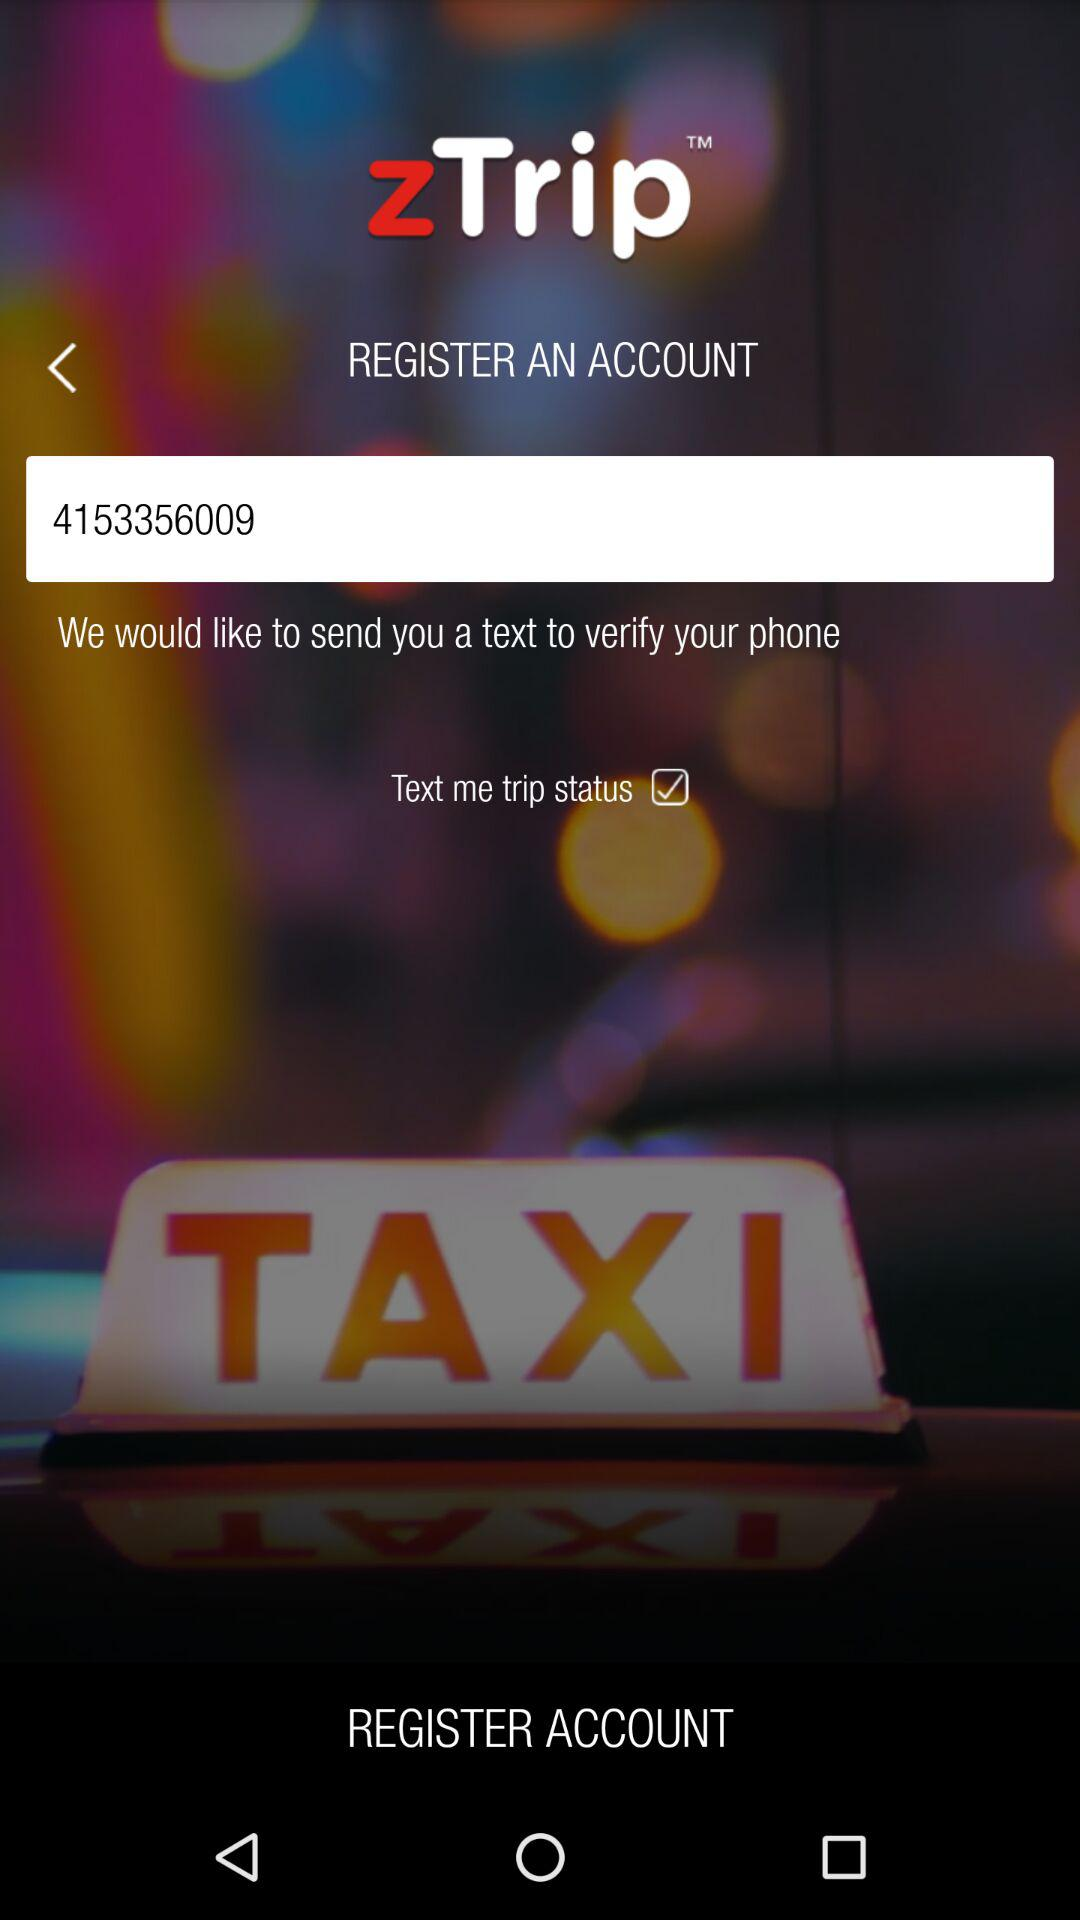What is the status of the "Text me trip status"? The status of the "Text me trip status" is "on". 